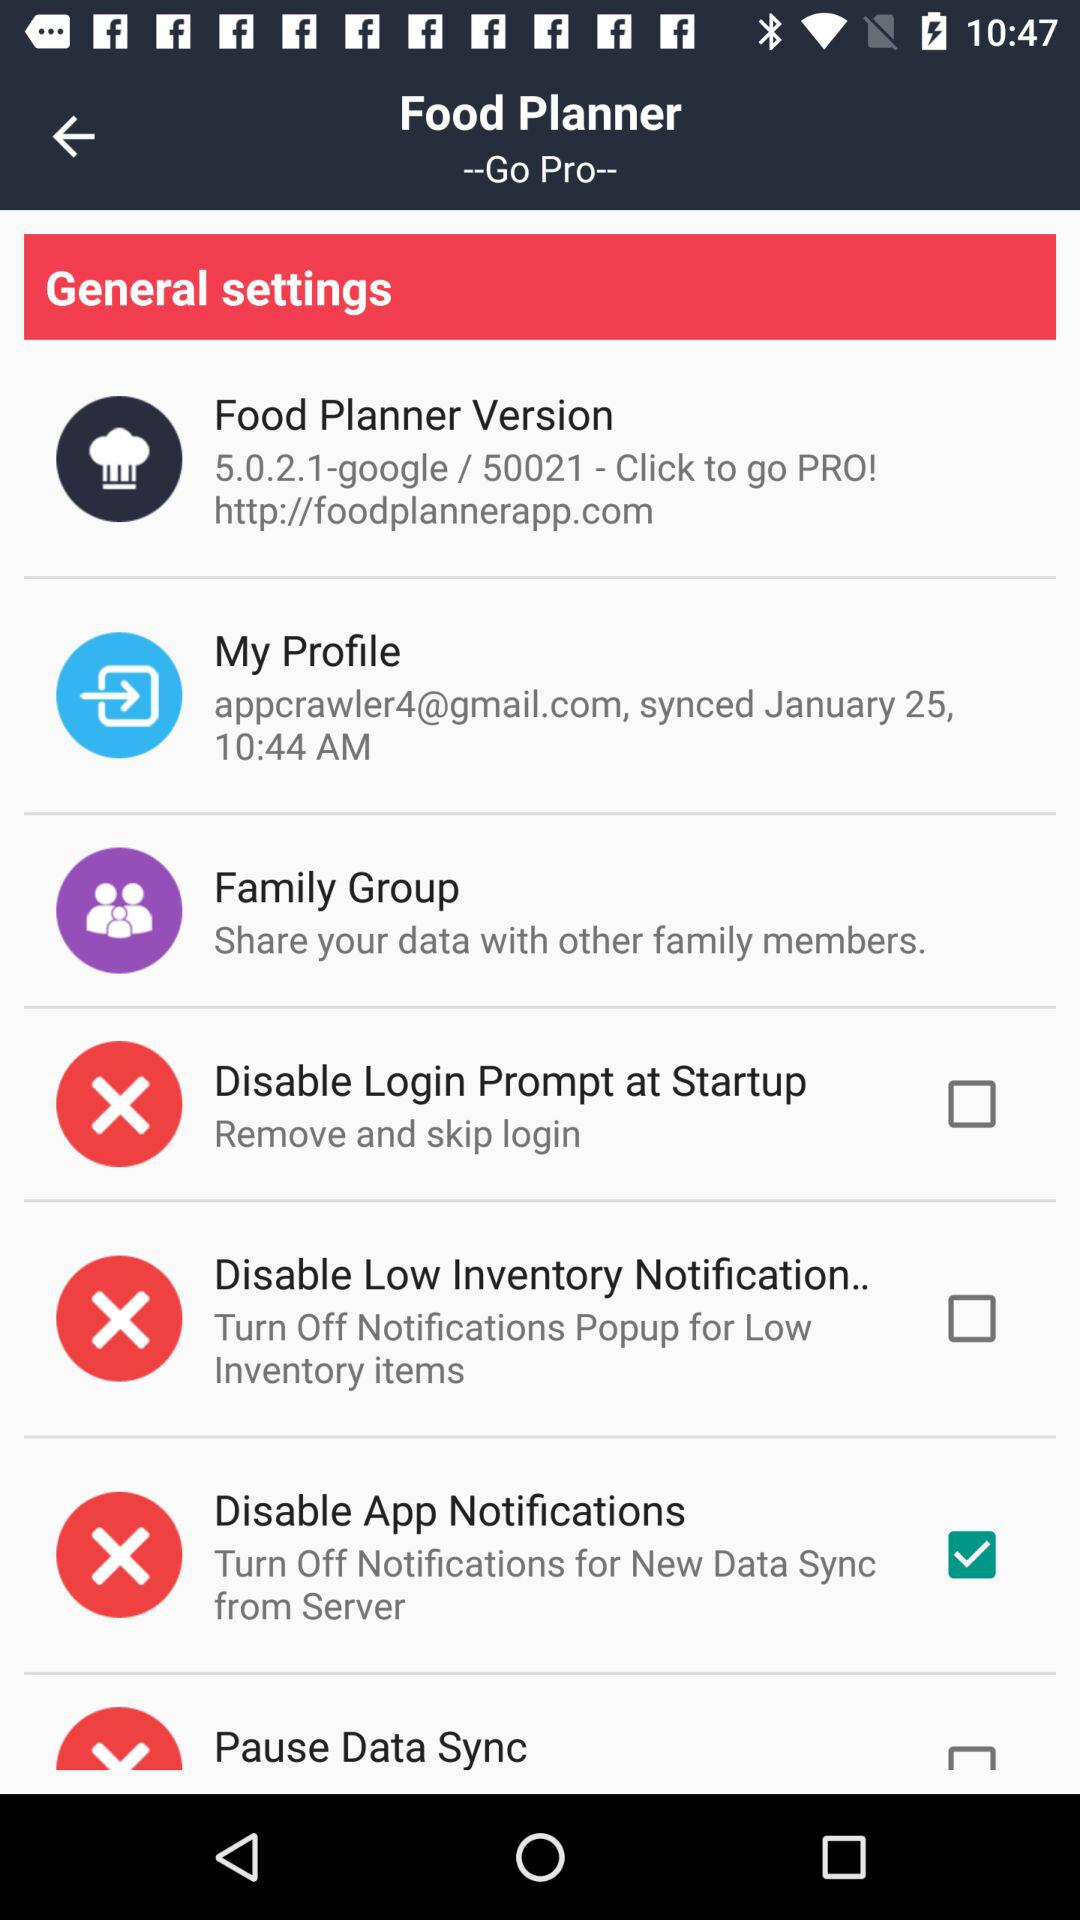What is the official website for the application? The official website for the application is http://foodplannerapp.com. 